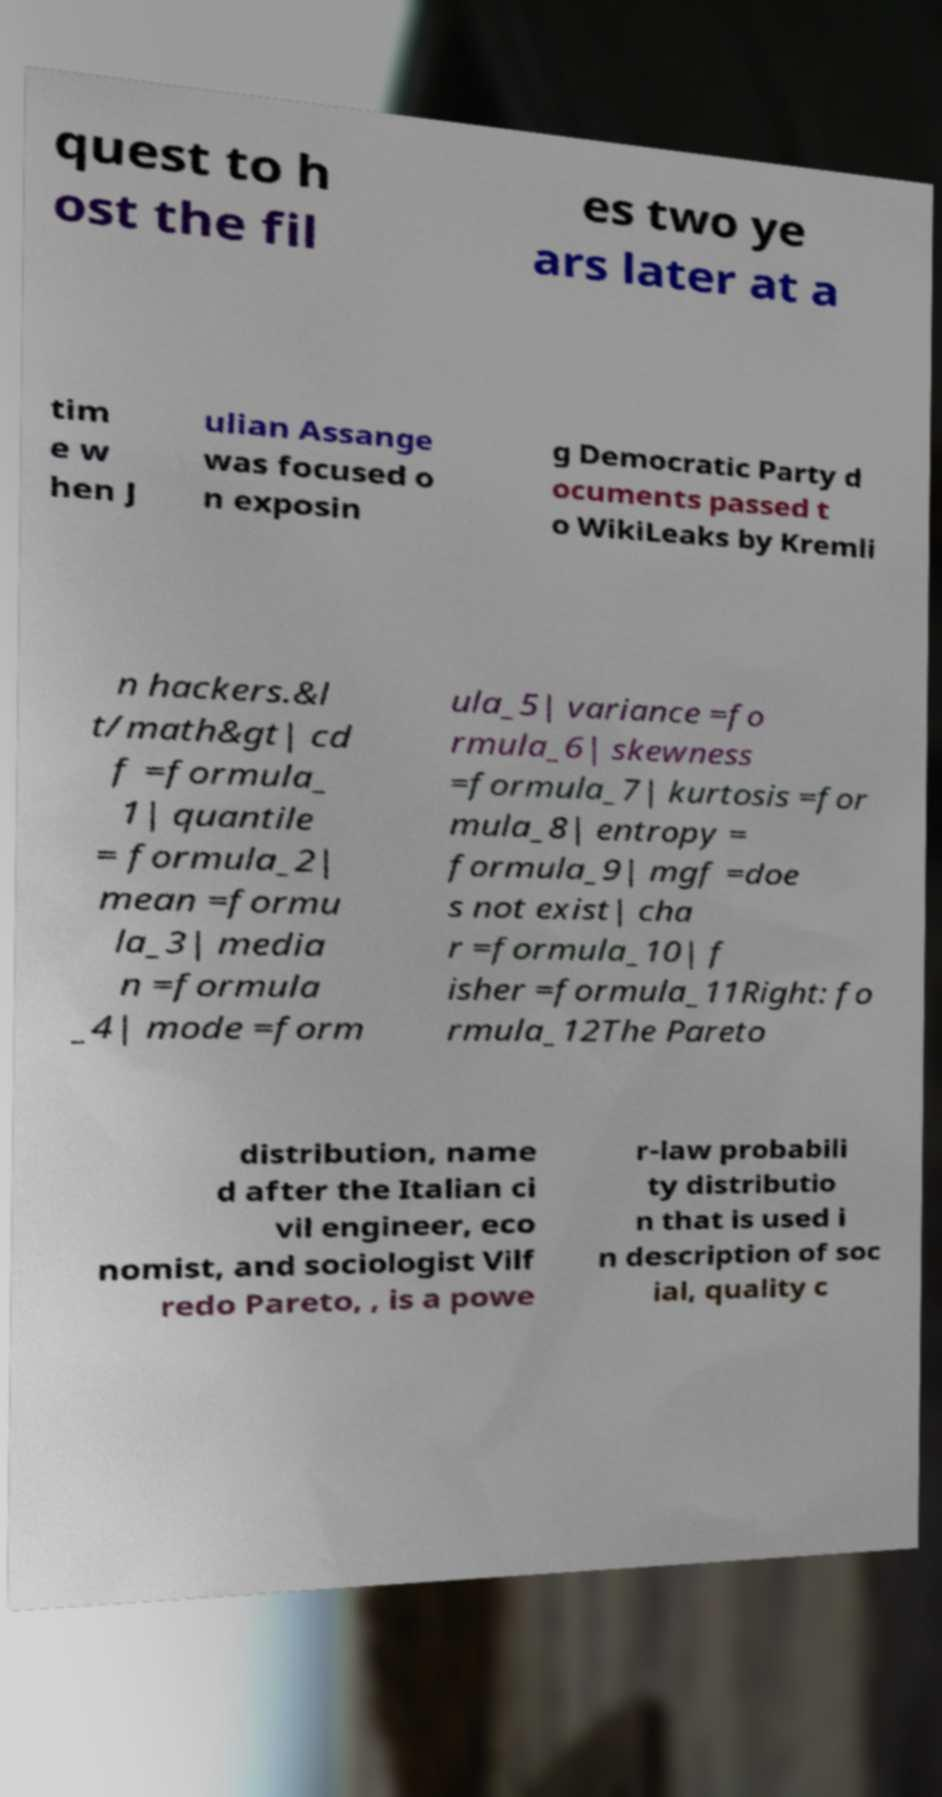Please identify and transcribe the text found in this image. quest to h ost the fil es two ye ars later at a tim e w hen J ulian Assange was focused o n exposin g Democratic Party d ocuments passed t o WikiLeaks by Kremli n hackers.&l t/math&gt| cd f =formula_ 1| quantile = formula_2| mean =formu la_3| media n =formula _4| mode =form ula_5| variance =fo rmula_6| skewness =formula_7| kurtosis =for mula_8| entropy = formula_9| mgf =doe s not exist| cha r =formula_10| f isher =formula_11Right: fo rmula_12The Pareto distribution, name d after the Italian ci vil engineer, eco nomist, and sociologist Vilf redo Pareto, , is a powe r-law probabili ty distributio n that is used i n description of soc ial, quality c 